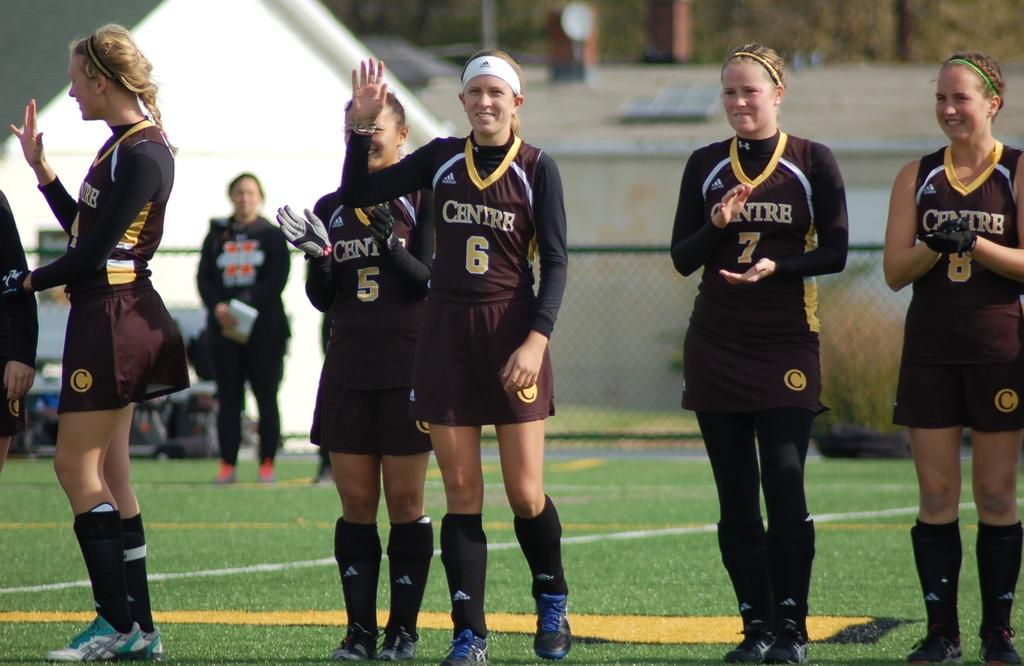<image>
Present a compact description of the photo's key features. Player number 6 for Centre waves to the crowd and wears a white headband. 